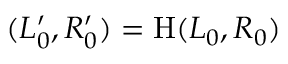Convert formula to latex. <formula><loc_0><loc_0><loc_500><loc_500>( L _ { 0 } ^ { \prime } , R _ { 0 } ^ { \prime } ) = H ( L _ { 0 } , R _ { 0 } )</formula> 